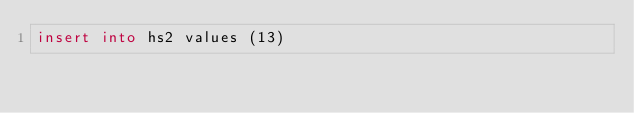Convert code to text. <code><loc_0><loc_0><loc_500><loc_500><_SQL_>insert into hs2 values (13)
</code> 